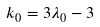<formula> <loc_0><loc_0><loc_500><loc_500>k _ { 0 } = 3 \lambda _ { 0 } - 3</formula> 